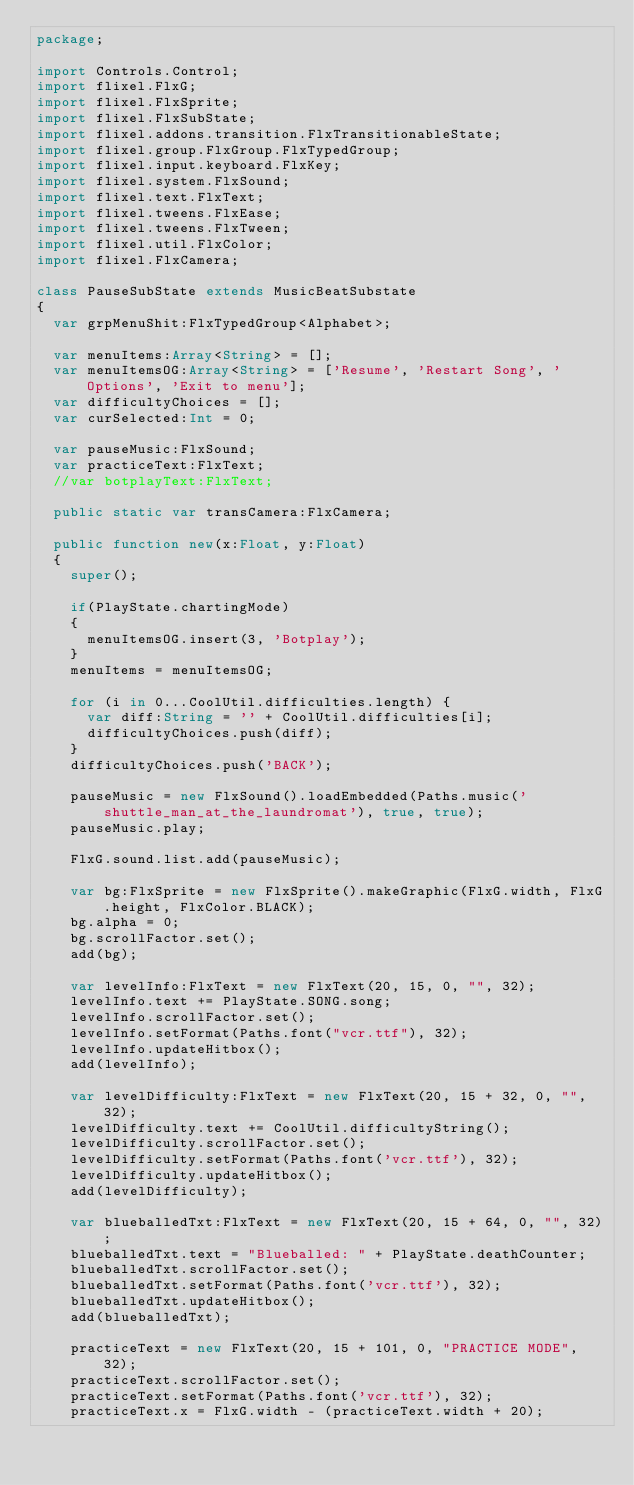<code> <loc_0><loc_0><loc_500><loc_500><_Haxe_>package;

import Controls.Control;
import flixel.FlxG;
import flixel.FlxSprite;
import flixel.FlxSubState;
import flixel.addons.transition.FlxTransitionableState;
import flixel.group.FlxGroup.FlxTypedGroup;
import flixel.input.keyboard.FlxKey;
import flixel.system.FlxSound;
import flixel.text.FlxText;
import flixel.tweens.FlxEase;
import flixel.tweens.FlxTween;
import flixel.util.FlxColor;
import flixel.FlxCamera;

class PauseSubState extends MusicBeatSubstate
{
	var grpMenuShit:FlxTypedGroup<Alphabet>;

	var menuItems:Array<String> = [];
	var menuItemsOG:Array<String> = ['Resume', 'Restart Song', 'Options', 'Exit to menu'];
	var difficultyChoices = [];
	var curSelected:Int = 0;

	var pauseMusic:FlxSound;
	var practiceText:FlxText;
	//var botplayText:FlxText;

	public static var transCamera:FlxCamera;

	public function new(x:Float, y:Float)
	{
		super();

		if(PlayState.chartingMode)
		{
			menuItemsOG.insert(3, 'Botplay');
		}
		menuItems = menuItemsOG;

		for (i in 0...CoolUtil.difficulties.length) {
			var diff:String = '' + CoolUtil.difficulties[i];
			difficultyChoices.push(diff);
		}
		difficultyChoices.push('BACK');

		pauseMusic = new FlxSound().loadEmbedded(Paths.music('shuttle_man_at_the_laundromat'), true, true);
		pauseMusic.play;

		FlxG.sound.list.add(pauseMusic);

		var bg:FlxSprite = new FlxSprite().makeGraphic(FlxG.width, FlxG.height, FlxColor.BLACK);
		bg.alpha = 0;
		bg.scrollFactor.set();
		add(bg);

		var levelInfo:FlxText = new FlxText(20, 15, 0, "", 32);
		levelInfo.text += PlayState.SONG.song;
		levelInfo.scrollFactor.set();
		levelInfo.setFormat(Paths.font("vcr.ttf"), 32);
		levelInfo.updateHitbox();
		add(levelInfo);

		var levelDifficulty:FlxText = new FlxText(20, 15 + 32, 0, "", 32);
		levelDifficulty.text += CoolUtil.difficultyString();
		levelDifficulty.scrollFactor.set();
		levelDifficulty.setFormat(Paths.font('vcr.ttf'), 32);
		levelDifficulty.updateHitbox();
		add(levelDifficulty);

		var blueballedTxt:FlxText = new FlxText(20, 15 + 64, 0, "", 32);
		blueballedTxt.text = "Blueballed: " + PlayState.deathCounter;
		blueballedTxt.scrollFactor.set();
		blueballedTxt.setFormat(Paths.font('vcr.ttf'), 32);
		blueballedTxt.updateHitbox();
		add(blueballedTxt);

		practiceText = new FlxText(20, 15 + 101, 0, "PRACTICE MODE", 32);
		practiceText.scrollFactor.set();
		practiceText.setFormat(Paths.font('vcr.ttf'), 32);
		practiceText.x = FlxG.width - (practiceText.width + 20);</code> 